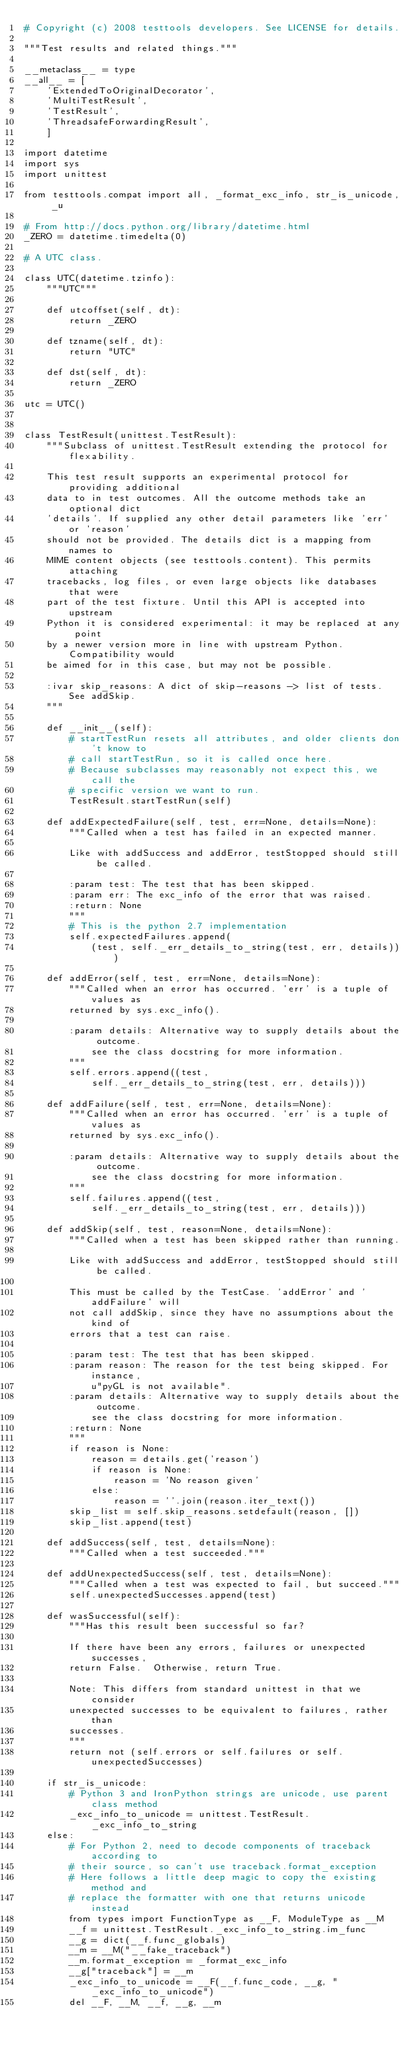<code> <loc_0><loc_0><loc_500><loc_500><_Python_># Copyright (c) 2008 testtools developers. See LICENSE for details.

"""Test results and related things."""

__metaclass__ = type
__all__ = [
    'ExtendedToOriginalDecorator',
    'MultiTestResult',
    'TestResult',
    'ThreadsafeForwardingResult',
    ]

import datetime
import sys
import unittest

from testtools.compat import all, _format_exc_info, str_is_unicode, _u

# From http://docs.python.org/library/datetime.html
_ZERO = datetime.timedelta(0)

# A UTC class.

class UTC(datetime.tzinfo):
    """UTC"""

    def utcoffset(self, dt):
        return _ZERO

    def tzname(self, dt):
        return "UTC"

    def dst(self, dt):
        return _ZERO

utc = UTC()


class TestResult(unittest.TestResult):
    """Subclass of unittest.TestResult extending the protocol for flexability.

    This test result supports an experimental protocol for providing additional
    data to in test outcomes. All the outcome methods take an optional dict
    'details'. If supplied any other detail parameters like 'err' or 'reason'
    should not be provided. The details dict is a mapping from names to
    MIME content objects (see testtools.content). This permits attaching
    tracebacks, log files, or even large objects like databases that were
    part of the test fixture. Until this API is accepted into upstream
    Python it is considered experimental: it may be replaced at any point
    by a newer version more in line with upstream Python. Compatibility would
    be aimed for in this case, but may not be possible.

    :ivar skip_reasons: A dict of skip-reasons -> list of tests. See addSkip.
    """

    def __init__(self):
        # startTestRun resets all attributes, and older clients don't know to
        # call startTestRun, so it is called once here.
        # Because subclasses may reasonably not expect this, we call the 
        # specific version we want to run.
        TestResult.startTestRun(self)

    def addExpectedFailure(self, test, err=None, details=None):
        """Called when a test has failed in an expected manner.

        Like with addSuccess and addError, testStopped should still be called.

        :param test: The test that has been skipped.
        :param err: The exc_info of the error that was raised.
        :return: None
        """
        # This is the python 2.7 implementation
        self.expectedFailures.append(
            (test, self._err_details_to_string(test, err, details)))

    def addError(self, test, err=None, details=None):
        """Called when an error has occurred. 'err' is a tuple of values as
        returned by sys.exc_info().

        :param details: Alternative way to supply details about the outcome.
            see the class docstring for more information.
        """
        self.errors.append((test,
            self._err_details_to_string(test, err, details)))

    def addFailure(self, test, err=None, details=None):
        """Called when an error has occurred. 'err' is a tuple of values as
        returned by sys.exc_info().

        :param details: Alternative way to supply details about the outcome.
            see the class docstring for more information.
        """
        self.failures.append((test,
            self._err_details_to_string(test, err, details)))

    def addSkip(self, test, reason=None, details=None):
        """Called when a test has been skipped rather than running.

        Like with addSuccess and addError, testStopped should still be called.

        This must be called by the TestCase. 'addError' and 'addFailure' will
        not call addSkip, since they have no assumptions about the kind of
        errors that a test can raise.

        :param test: The test that has been skipped.
        :param reason: The reason for the test being skipped. For instance,
            u"pyGL is not available".
        :param details: Alternative way to supply details about the outcome.
            see the class docstring for more information.
        :return: None
        """
        if reason is None:
            reason = details.get('reason')
            if reason is None:
                reason = 'No reason given'
            else:
                reason = ''.join(reason.iter_text())
        skip_list = self.skip_reasons.setdefault(reason, [])
        skip_list.append(test)

    def addSuccess(self, test, details=None):
        """Called when a test succeeded."""

    def addUnexpectedSuccess(self, test, details=None):
        """Called when a test was expected to fail, but succeed."""
        self.unexpectedSuccesses.append(test)

    def wasSuccessful(self):
        """Has this result been successful so far?

        If there have been any errors, failures or unexpected successes,
        return False.  Otherwise, return True.

        Note: This differs from standard unittest in that we consider
        unexpected successes to be equivalent to failures, rather than
        successes.
        """
        return not (self.errors or self.failures or self.unexpectedSuccesses)

    if str_is_unicode:
        # Python 3 and IronPython strings are unicode, use parent class method
        _exc_info_to_unicode = unittest.TestResult._exc_info_to_string
    else:
        # For Python 2, need to decode components of traceback according to
        # their source, so can't use traceback.format_exception
        # Here follows a little deep magic to copy the existing method and
        # replace the formatter with one that returns unicode instead
        from types import FunctionType as __F, ModuleType as __M
        __f = unittest.TestResult._exc_info_to_string.im_func
        __g = dict(__f.func_globals)
        __m = __M("__fake_traceback")
        __m.format_exception = _format_exc_info
        __g["traceback"] = __m
        _exc_info_to_unicode = __F(__f.func_code, __g, "_exc_info_to_unicode")
        del __F, __M, __f, __g, __m
</code> 